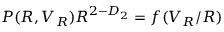Convert formula to latex. <formula><loc_0><loc_0><loc_500><loc_500>P ( R , V _ { R } ) R ^ { { 2 } - D _ { 2 } } = f ( V _ { R } / R )</formula> 